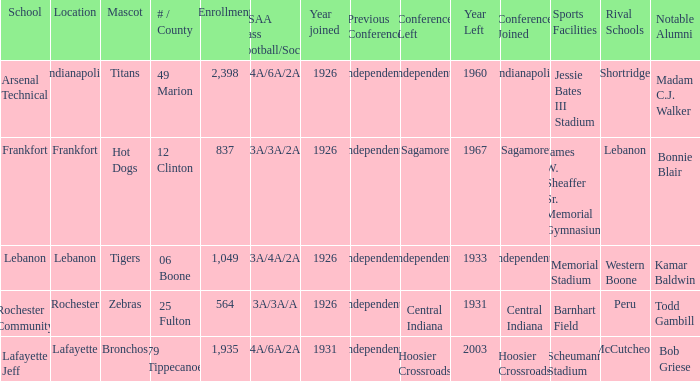What is the lowest enrollment that has Lafayette as the location? 1935.0. 